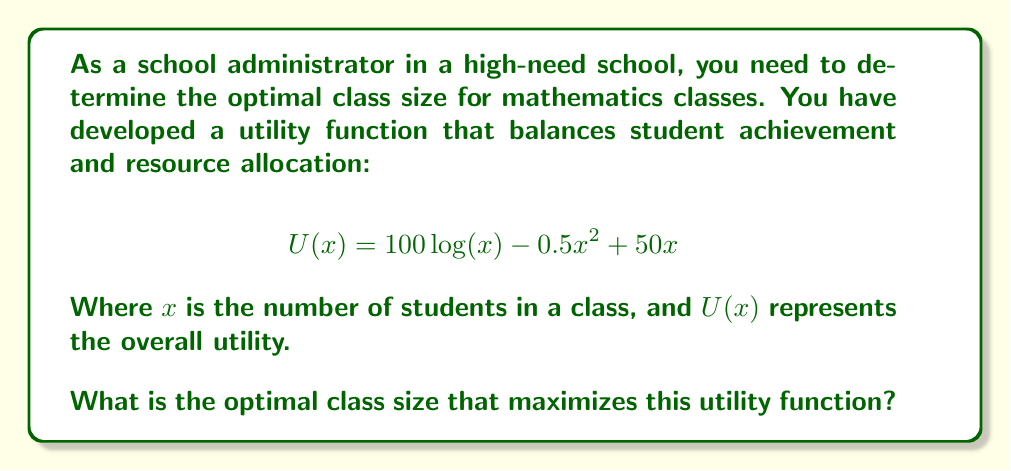Provide a solution to this math problem. To find the optimal class size, we need to maximize the utility function $U(x)$. This can be done by finding the value of $x$ where the derivative of $U(x)$ equals zero.

Step 1: Calculate the derivative of $U(x)$
$$U'(x) = \frac{100}{x} - x + 50$$

Step 2: Set the derivative equal to zero and solve for $x$
$$\frac{100}{x} - x + 50 = 0$$
$$100 - x^2 + 50x = 0$$
$$x^2 - 50x - 100 = 0$$

Step 3: Use the quadratic formula to solve for $x$
$$x = \frac{-b \pm \sqrt{b^2 - 4ac}}{2a}$$
Where $a=1$, $b=-50$, and $c=-100$

$$x = \frac{50 \pm \sqrt{2500 + 400}}{2} = \frac{50 \pm \sqrt{2900}}{2}$$

Step 4: Simplify and calculate the two solutions
$$x_1 = \frac{50 + \sqrt{2900}}{2} \approx 51.95$$
$$x_2 = \frac{50 - \sqrt{2900}}{2} \approx -1.95$$

Step 5: Discard the negative solution as it's not practical for class size

Step 6: Round to the nearest whole number, as we can't have fractional students

Therefore, the optimal class size is 52 students.
Answer: 52 students 